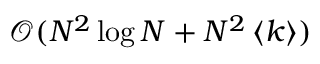Convert formula to latex. <formula><loc_0><loc_0><loc_500><loc_500>\mathcal { O } ( N ^ { 2 } \log N + N ^ { 2 } \left < k \right > )</formula> 